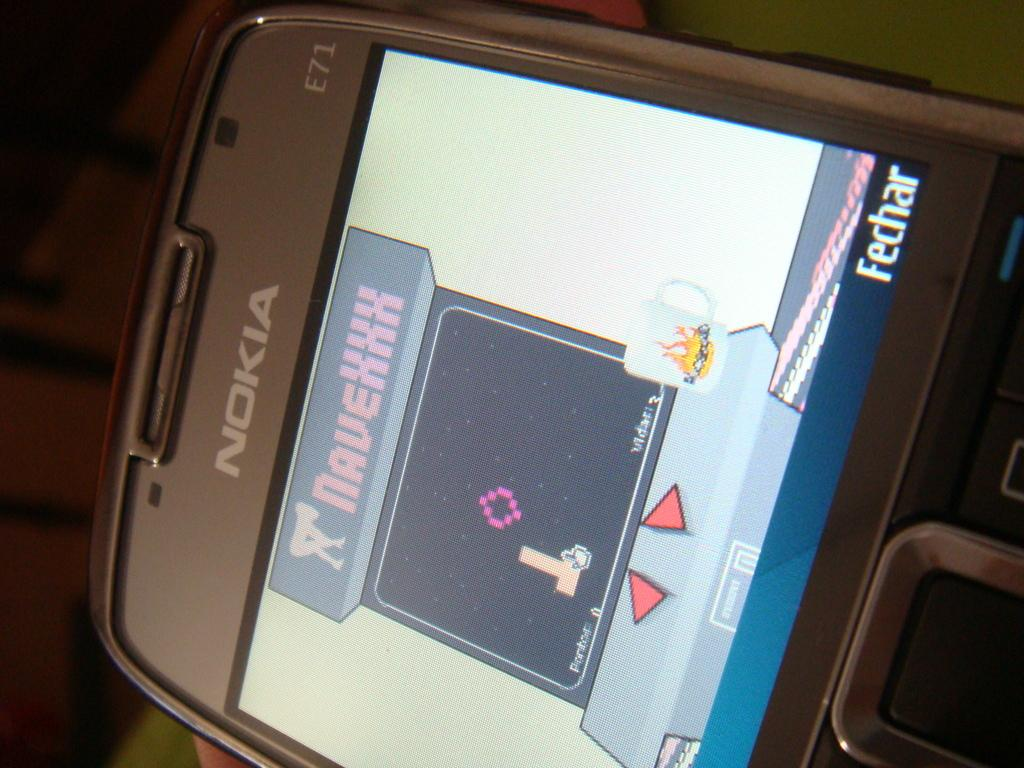Provide a one-sentence caption for the provided image. a Nokia phone with a screen of game NaveXXX showing. 